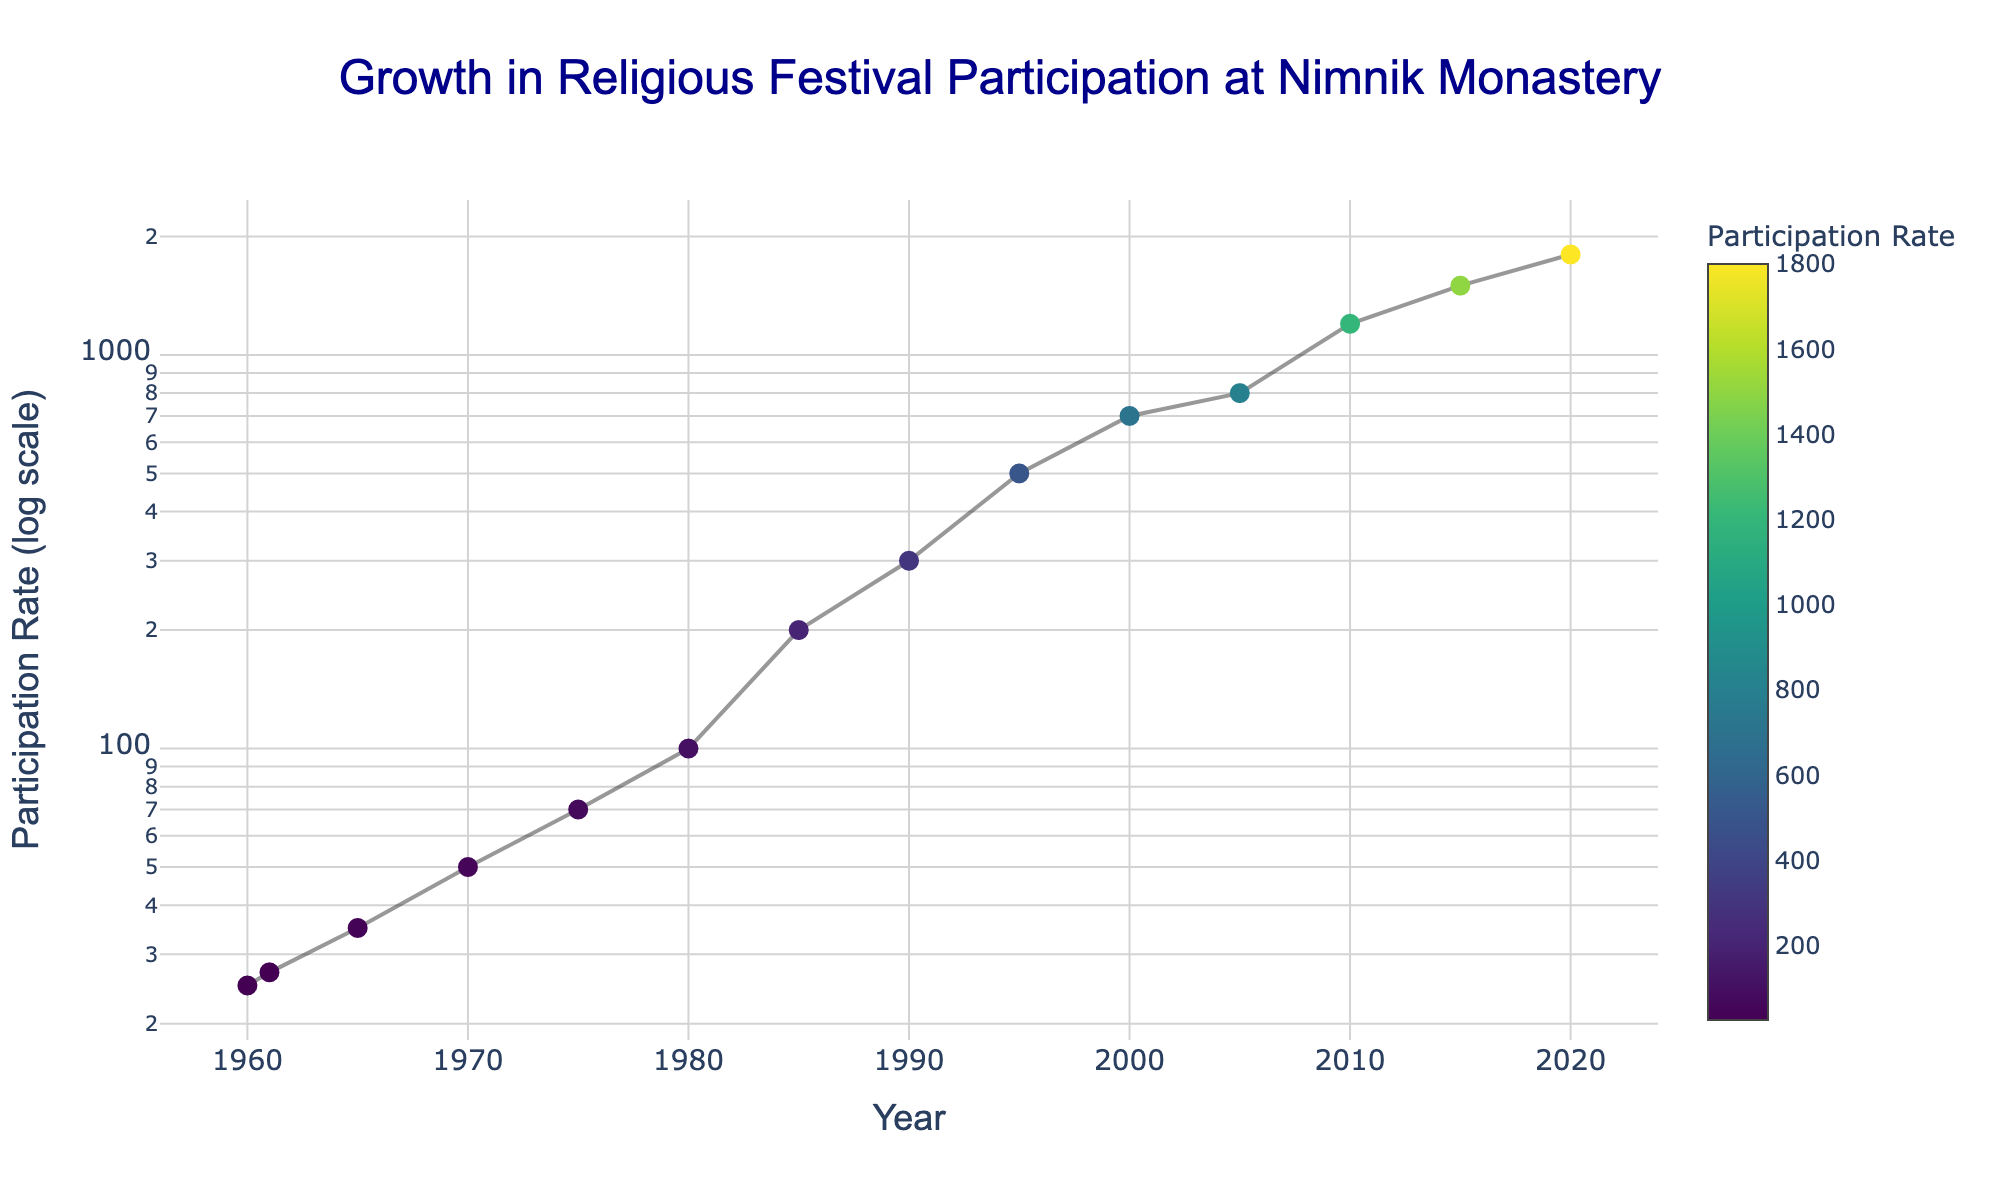What is the title of the figure? The title can be found at the top of the figure. It reads "Growth in Religious Festival Participation at Nimnik Monastery".
Answer: Growth in Religious Festival Participation at Nimnik Monastery What is the participation rate in the year 1980? The participation rate for each year can be read off the y-axis next to the corresponding year on the x-axis. For 1980, the participation rate is 100.
Answer: 100 What were the first and last years the Spring Equinox Festival was recorded? Identify the years labeled as "Spring Equinox Festival". The first year is 1960 and the last year is 2000.
Answer: 1960 and 2000 How does the participation rate trend from 1960 to 2020? Observe the points and their connecting lines on the scatter plot from 1960 to 2020. Overall, the participation rate shows a significant increase over time, particularly visibly increasing from around 1980 onwards.
Answer: Increased significantly How many festivals are recorded between the years 1960 and 2020? Count all the individual data points shown on the scatter plot between these years. There are total of 14 data points.
Answer: 14 What is the participation rate difference between the first Summer Solstice Festival and the last Spring Equinox Festival? Locate the participation rates for the first Summer Solstice Festival (2005, 800) and the last Spring Equinox Festival (2000, 700). Subtract the two rates: 800 - 700 = 100.
Answer: 100 Which festival shows a higher overall participation rate - Spring Equinox or Summer Solstice? Compare the participation rates of each festival. The Summer Solstice Festival consistently shows higher rates starting from 800 to 1800, while the Spring Equinox Festival ranges from 25 to 700.
Answer: Summer Solstice Festival When did the participation rate first exceed 1000? Look at the scatter plot to see at which year the participation rate crosses 1000. It first exceeds in the year 2010.
Answer: 2010 What was the rate of increase in participation from 1980 to 1990? Calculate the difference between the participation rates in these years. For 1990, it's 300; for 1980, it's 100. So, the rate of increase = (300 - 100) / 1980 to 1990 = 200 over 10 years, therefore 20 per year.
Answer: 20 per year 